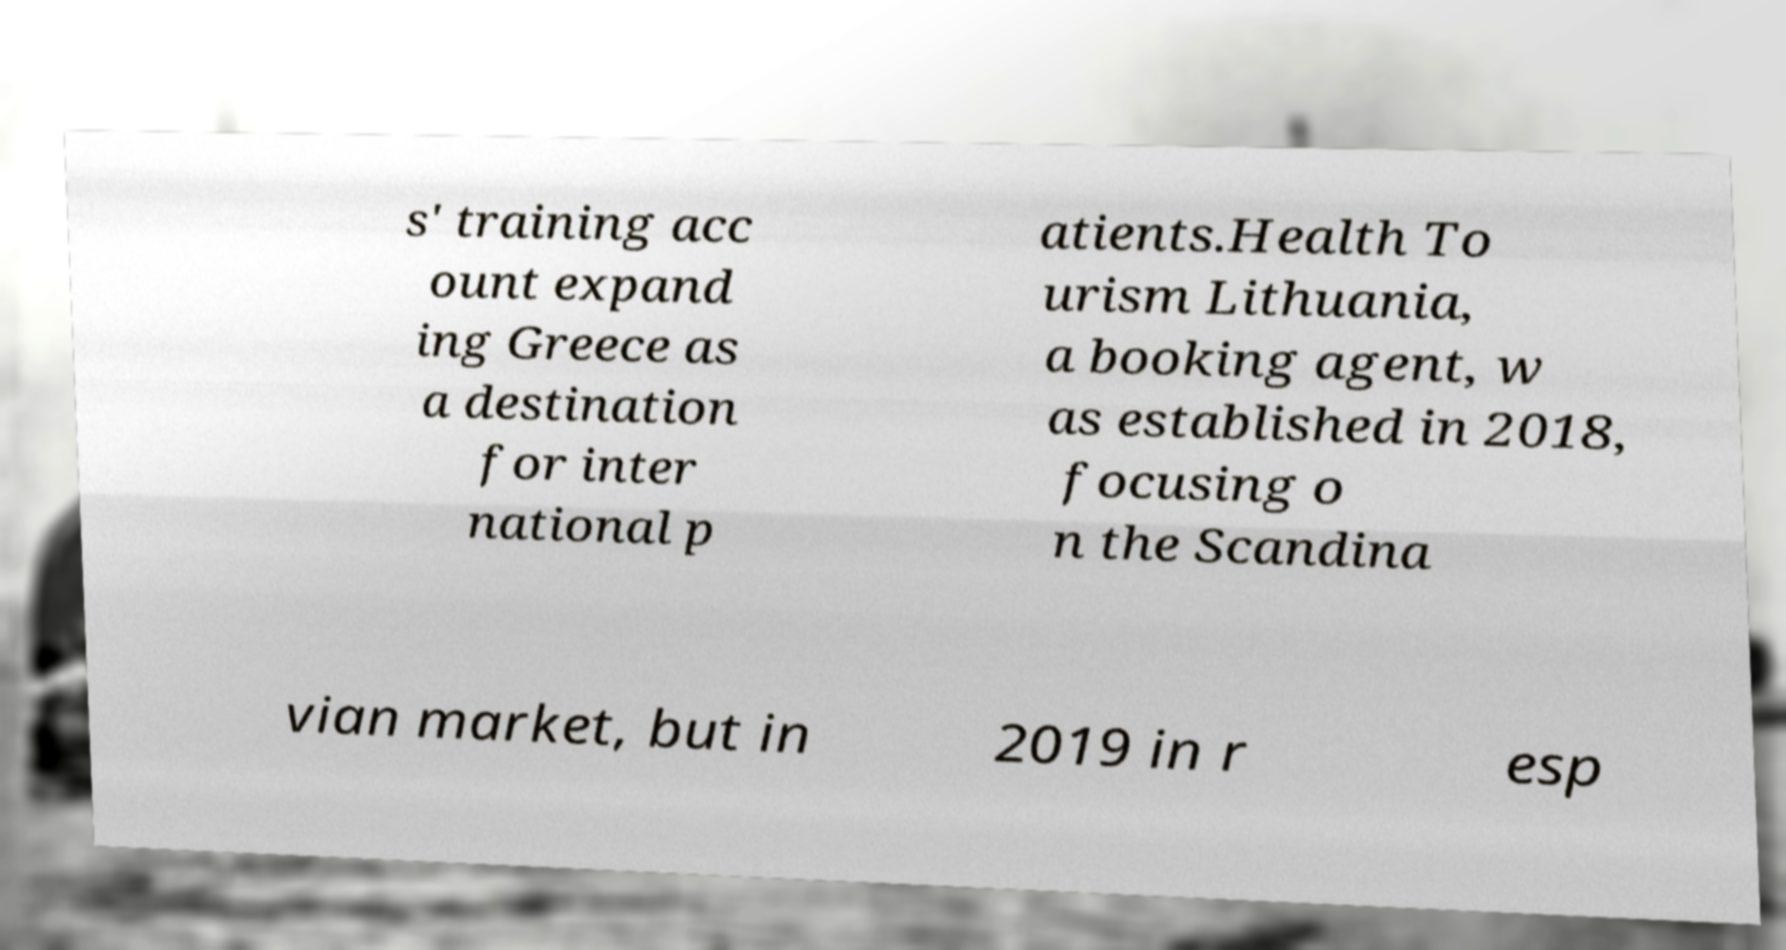There's text embedded in this image that I need extracted. Can you transcribe it verbatim? s' training acc ount expand ing Greece as a destination for inter national p atients.Health To urism Lithuania, a booking agent, w as established in 2018, focusing o n the Scandina vian market, but in 2019 in r esp 